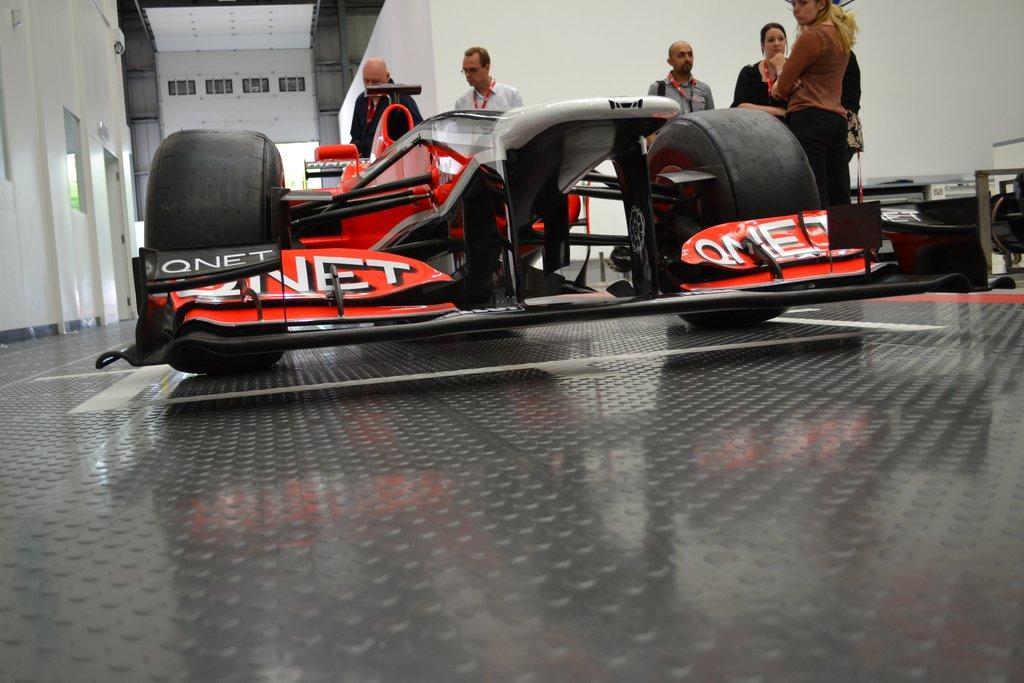Could you give a brief overview of what you see in this image? In this image we can see a vehicle on the floor. In the background, we can see these people are standing and we can see few things here. Here we can see the wall. 